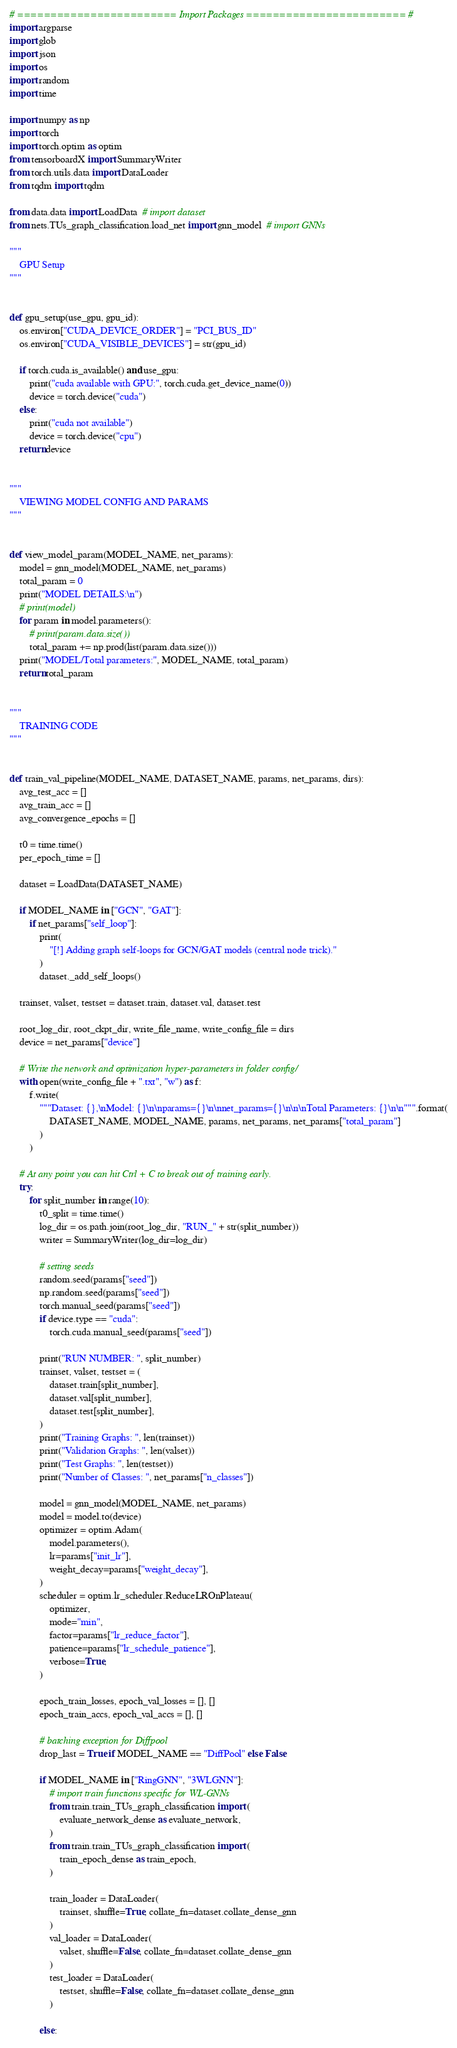<code> <loc_0><loc_0><loc_500><loc_500><_Python_># ======================== Import Packages ======================== #
import argparse
import glob
import json
import os
import random
import time

import numpy as np
import torch
import torch.optim as optim
from tensorboardX import SummaryWriter
from torch.utils.data import DataLoader
from tqdm import tqdm

from data.data import LoadData  # import dataset
from nets.TUs_graph_classification.load_net import gnn_model  # import GNNs

"""
    GPU Setup
"""


def gpu_setup(use_gpu, gpu_id):
    os.environ["CUDA_DEVICE_ORDER"] = "PCI_BUS_ID"
    os.environ["CUDA_VISIBLE_DEVICES"] = str(gpu_id)

    if torch.cuda.is_available() and use_gpu:
        print("cuda available with GPU:", torch.cuda.get_device_name(0))
        device = torch.device("cuda")
    else:
        print("cuda not available")
        device = torch.device("cpu")
    return device


"""
    VIEWING MODEL CONFIG AND PARAMS
"""


def view_model_param(MODEL_NAME, net_params):
    model = gnn_model(MODEL_NAME, net_params)
    total_param = 0
    print("MODEL DETAILS:\n")
    # print(model)
    for param in model.parameters():
        # print(param.data.size())
        total_param += np.prod(list(param.data.size()))
    print("MODEL/Total parameters:", MODEL_NAME, total_param)
    return total_param


"""
    TRAINING CODE
"""


def train_val_pipeline(MODEL_NAME, DATASET_NAME, params, net_params, dirs):
    avg_test_acc = []
    avg_train_acc = []
    avg_convergence_epochs = []

    t0 = time.time()
    per_epoch_time = []

    dataset = LoadData(DATASET_NAME)

    if MODEL_NAME in ["GCN", "GAT"]:
        if net_params["self_loop"]:
            print(
                "[!] Adding graph self-loops for GCN/GAT models (central node trick)."
            )
            dataset._add_self_loops()

    trainset, valset, testset = dataset.train, dataset.val, dataset.test

    root_log_dir, root_ckpt_dir, write_file_name, write_config_file = dirs
    device = net_params["device"]

    # Write the network and optimization hyper-parameters in folder config/
    with open(write_config_file + ".txt", "w") as f:
        f.write(
            """Dataset: {},\nModel: {}\n\nparams={}\n\nnet_params={}\n\n\nTotal Parameters: {}\n\n""".format(
                DATASET_NAME, MODEL_NAME, params, net_params, net_params["total_param"]
            )
        )

    # At any point you can hit Ctrl + C to break out of training early.
    try:
        for split_number in range(10):
            t0_split = time.time()
            log_dir = os.path.join(root_log_dir, "RUN_" + str(split_number))
            writer = SummaryWriter(log_dir=log_dir)

            # setting seeds
            random.seed(params["seed"])
            np.random.seed(params["seed"])
            torch.manual_seed(params["seed"])
            if device.type == "cuda":
                torch.cuda.manual_seed(params["seed"])

            print("RUN NUMBER: ", split_number)
            trainset, valset, testset = (
                dataset.train[split_number],
                dataset.val[split_number],
                dataset.test[split_number],
            )
            print("Training Graphs: ", len(trainset))
            print("Validation Graphs: ", len(valset))
            print("Test Graphs: ", len(testset))
            print("Number of Classes: ", net_params["n_classes"])

            model = gnn_model(MODEL_NAME, net_params)
            model = model.to(device)
            optimizer = optim.Adam(
                model.parameters(),
                lr=params["init_lr"],
                weight_decay=params["weight_decay"],
            )
            scheduler = optim.lr_scheduler.ReduceLROnPlateau(
                optimizer,
                mode="min",
                factor=params["lr_reduce_factor"],
                patience=params["lr_schedule_patience"],
                verbose=True,
            )

            epoch_train_losses, epoch_val_losses = [], []
            epoch_train_accs, epoch_val_accs = [], []

            # batching exception for Diffpool
            drop_last = True if MODEL_NAME == "DiffPool" else False

            if MODEL_NAME in ["RingGNN", "3WLGNN"]:
                # import train functions specific for WL-GNNs
                from train.train_TUs_graph_classification import (
                    evaluate_network_dense as evaluate_network,
                )
                from train.train_TUs_graph_classification import (
                    train_epoch_dense as train_epoch,
                )

                train_loader = DataLoader(
                    trainset, shuffle=True, collate_fn=dataset.collate_dense_gnn
                )
                val_loader = DataLoader(
                    valset, shuffle=False, collate_fn=dataset.collate_dense_gnn
                )
                test_loader = DataLoader(
                    testset, shuffle=False, collate_fn=dataset.collate_dense_gnn
                )

            else:</code> 